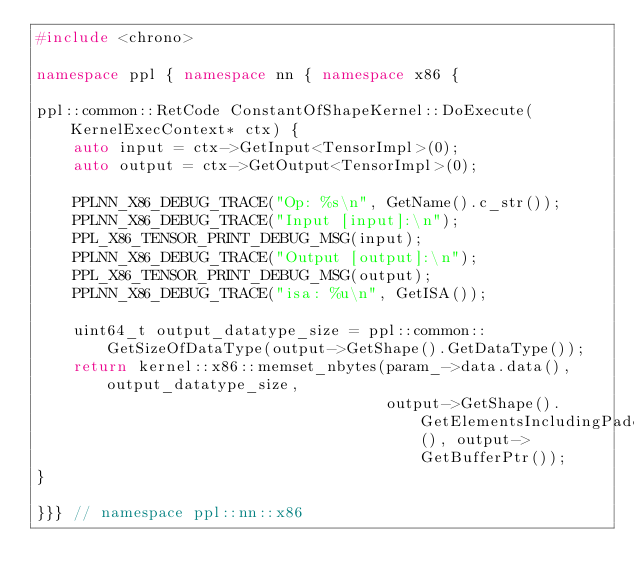<code> <loc_0><loc_0><loc_500><loc_500><_C++_>#include <chrono>

namespace ppl { namespace nn { namespace x86 {

ppl::common::RetCode ConstantOfShapeKernel::DoExecute(KernelExecContext* ctx) {
    auto input = ctx->GetInput<TensorImpl>(0);
    auto output = ctx->GetOutput<TensorImpl>(0);

    PPLNN_X86_DEBUG_TRACE("Op: %s\n", GetName().c_str());
    PPLNN_X86_DEBUG_TRACE("Input [input]:\n");
    PPL_X86_TENSOR_PRINT_DEBUG_MSG(input);
    PPLNN_X86_DEBUG_TRACE("Output [output]:\n");
    PPL_X86_TENSOR_PRINT_DEBUG_MSG(output);
    PPLNN_X86_DEBUG_TRACE("isa: %u\n", GetISA());

    uint64_t output_datatype_size = ppl::common::GetSizeOfDataType(output->GetShape().GetDataType());
    return kernel::x86::memset_nbytes(param_->data.data(), output_datatype_size,
                                      output->GetShape().GetElementsIncludingPadding(), output->GetBufferPtr());
}

}}} // namespace ppl::nn::x86
</code> 